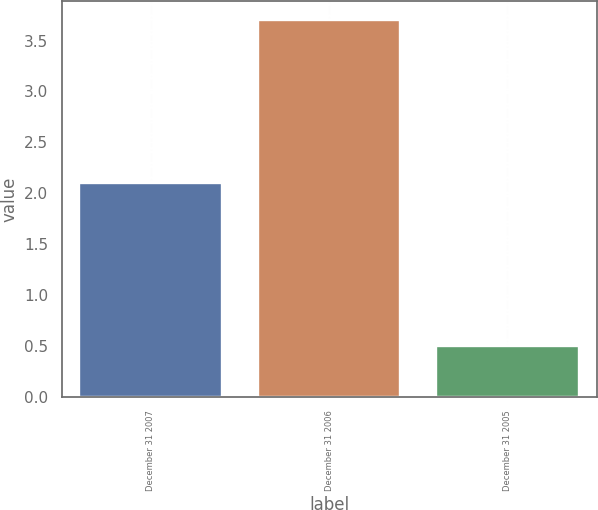<chart> <loc_0><loc_0><loc_500><loc_500><bar_chart><fcel>December 31 2007<fcel>December 31 2006<fcel>December 31 2005<nl><fcel>2.1<fcel>3.7<fcel>0.5<nl></chart> 